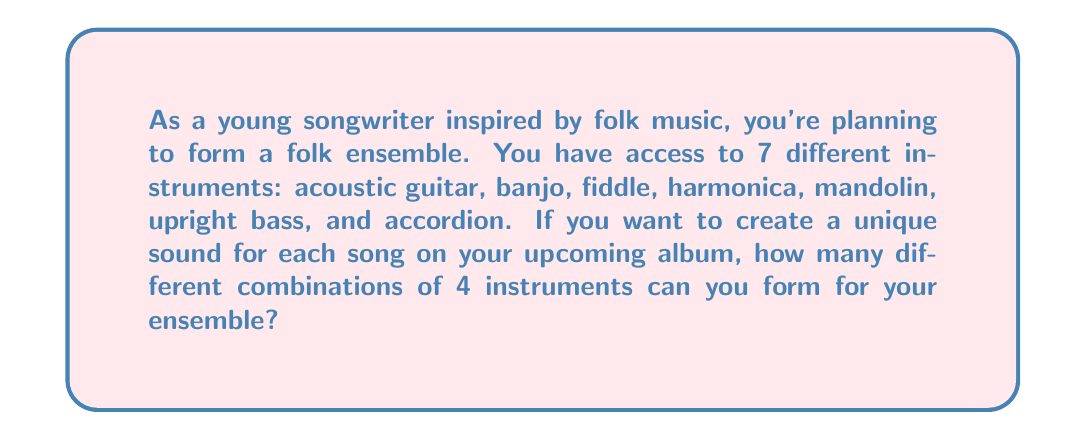Teach me how to tackle this problem. To solve this problem, we need to use the combination formula. We are selecting 4 instruments out of 7, where the order doesn't matter (e.g., guitar-banjo-fiddle-harmonica is considered the same combination as banjo-fiddle-harmonica-guitar).

The formula for combinations is:

$$C(n,r) = \frac{n!}{r!(n-r)!}$$

Where:
$n$ is the total number of items to choose from (in this case, 7 instruments)
$r$ is the number of items being chosen (in this case, 4 instruments)

Let's plug in our values:

$$C(7,4) = \frac{7!}{4!(7-4)!} = \frac{7!}{4!3!}$$

Now, let's calculate this step by step:

1) $7! = 7 \times 6 \times 5 \times 4 \times 3 \times 2 \times 1 = 5040$
2) $4! = 4 \times 3 \times 2 \times 1 = 24$
3) $3! = 3 \times 2 \times 1 = 6$

Plugging these values back into our equation:

$$\frac{7!}{4!3!} = \frac{5040}{24 \times 6} = \frac{5040}{144} = 35$$

Therefore, you can form 35 different combinations of 4 instruments for your folk ensemble.
Answer: 35 combinations 